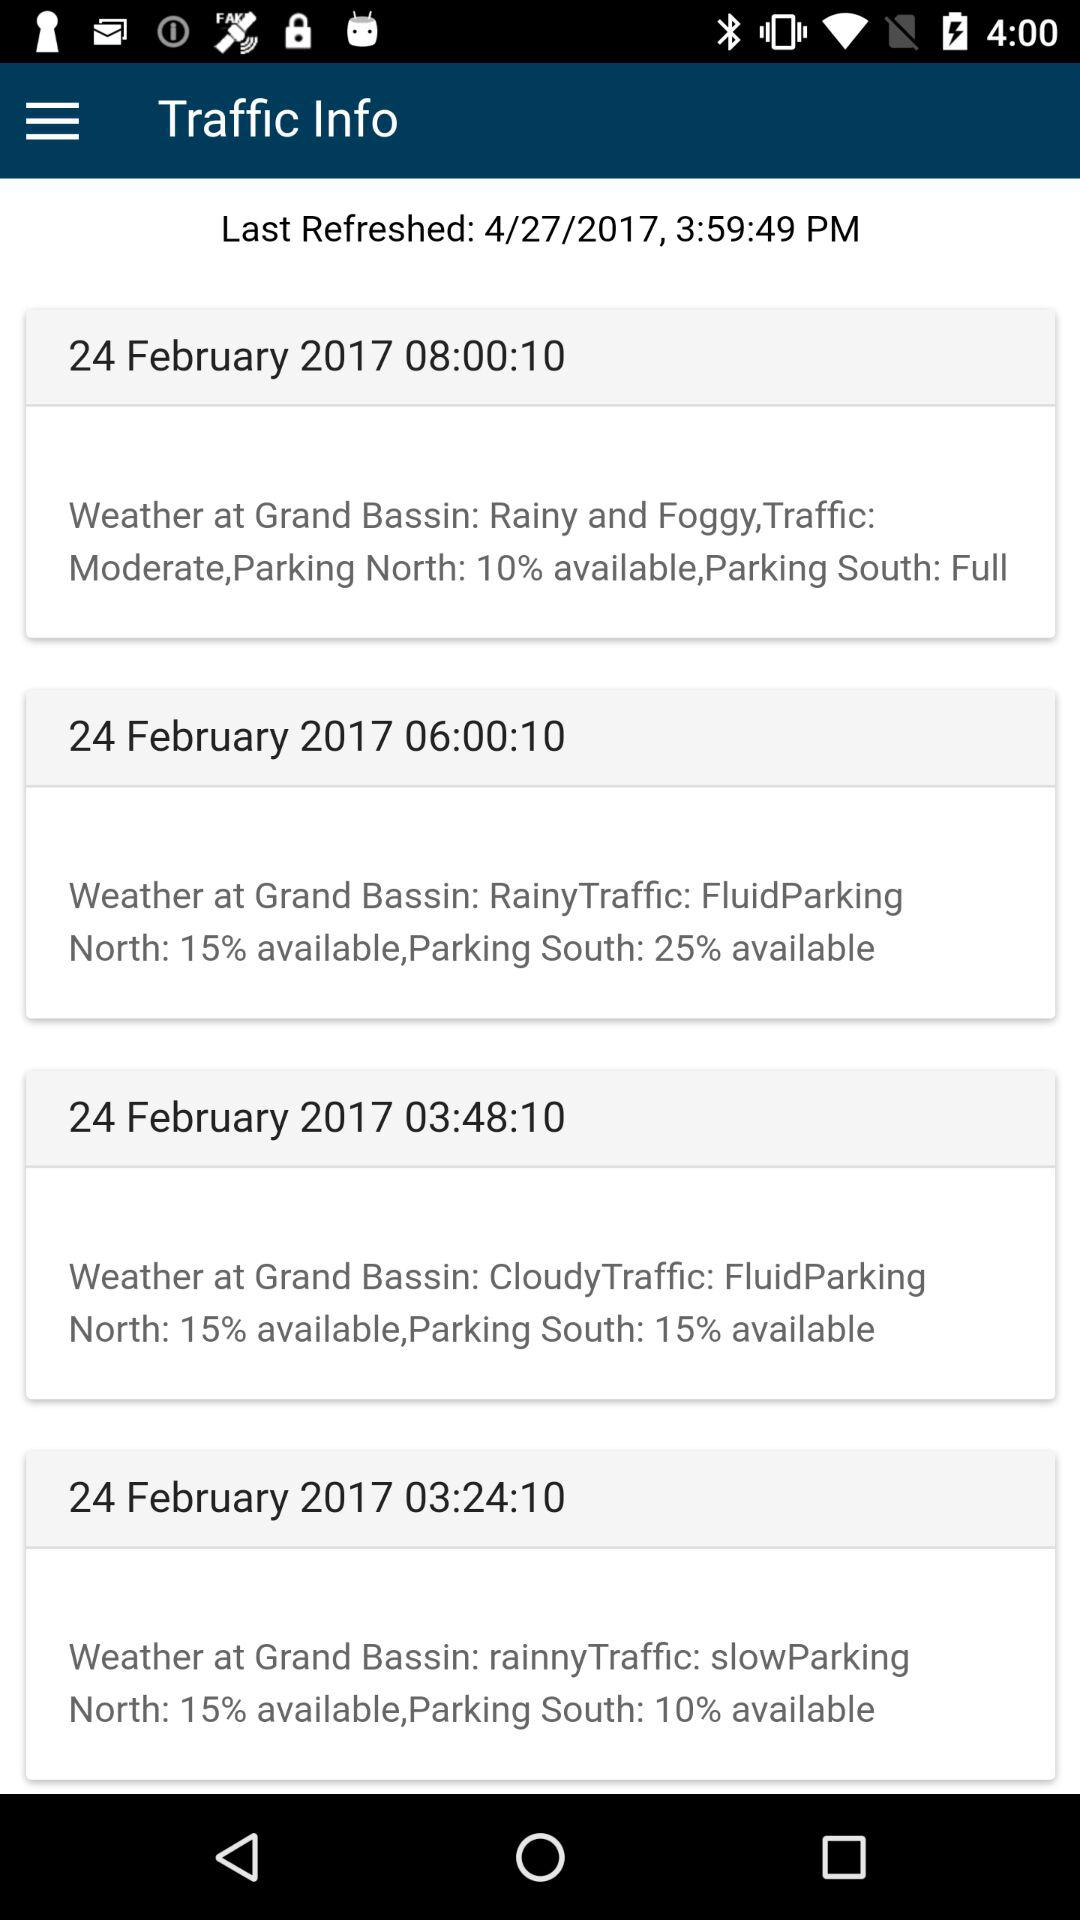What is the time when south parking is 25%? The time when south parking is 25% is 06:00:10. 